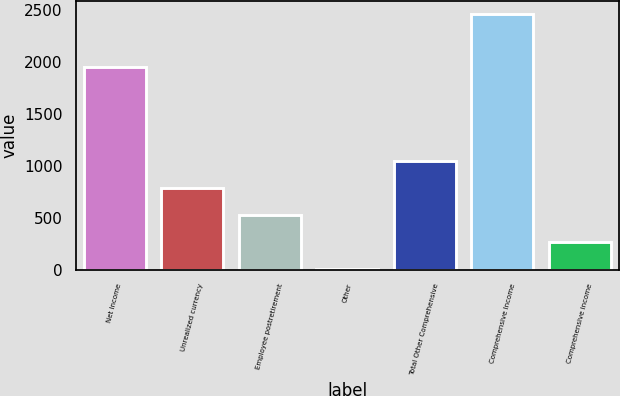Convert chart. <chart><loc_0><loc_0><loc_500><loc_500><bar_chart><fcel>Net Income<fcel>Unrealized currency<fcel>Employee postretirement<fcel>Other<fcel>Total Other Comprehensive<fcel>Comprehensive Income<fcel>Comprehensive income<nl><fcel>1951<fcel>788.2<fcel>528.8<fcel>10<fcel>1047.6<fcel>2464<fcel>269.4<nl></chart> 